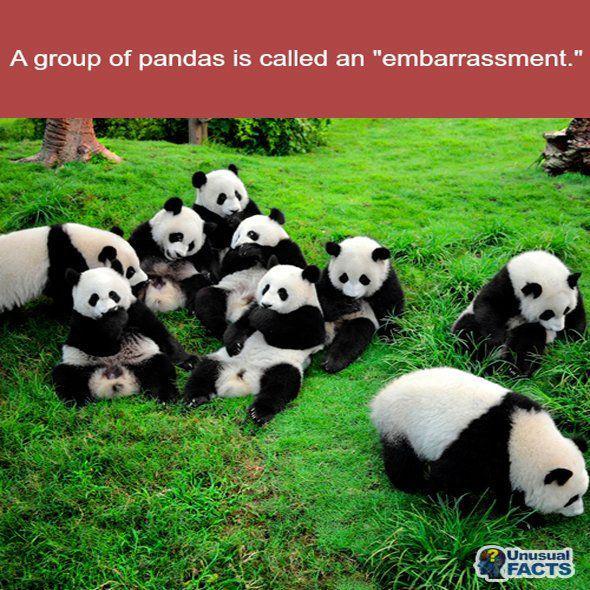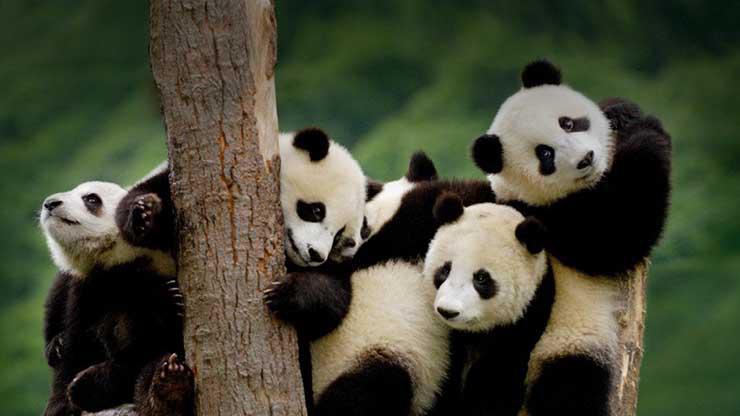The first image is the image on the left, the second image is the image on the right. Examine the images to the left and right. Is the description "An image shows multiple pandas with green stalks for munching, on a structure of joined logs." accurate? Answer yes or no. No. The first image is the image on the left, the second image is the image on the right. Examine the images to the left and right. Is the description "At least one panda is sitting in an open grassy area in one of the images." accurate? Answer yes or no. Yes. 